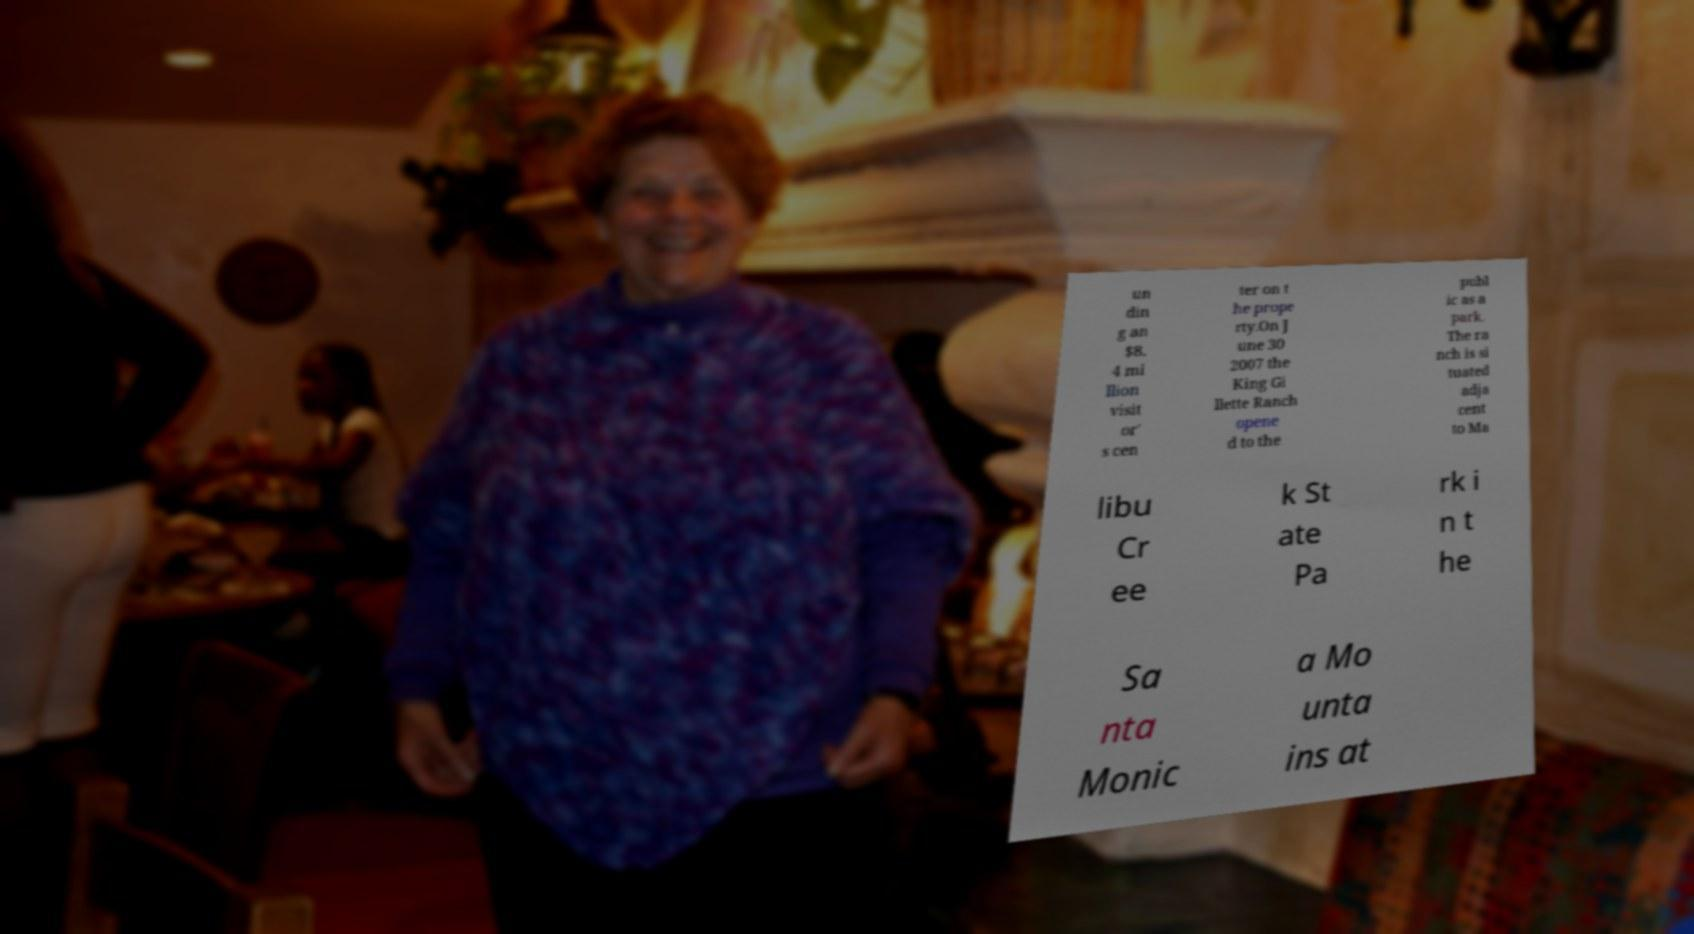Could you extract and type out the text from this image? un din g an $8. 4 mi llion visit or' s cen ter on t he prope rty.On J une 30 2007 the King Gi llette Ranch opene d to the publ ic as a park. The ra nch is si tuated adja cent to Ma libu Cr ee k St ate Pa rk i n t he Sa nta Monic a Mo unta ins at 